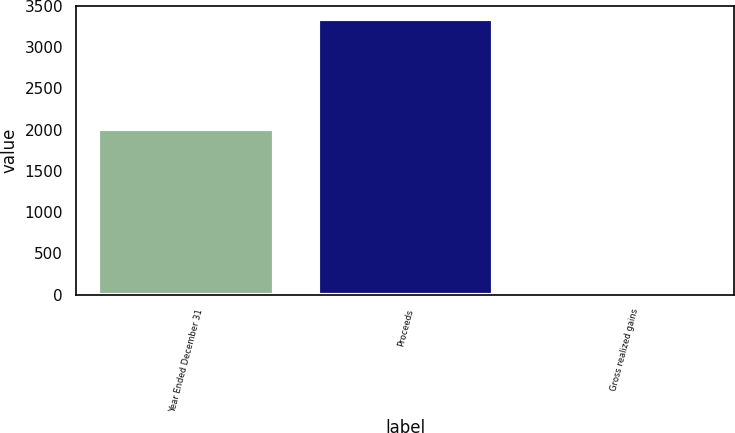Convert chart to OTSL. <chart><loc_0><loc_0><loc_500><loc_500><bar_chart><fcel>Year Ended December 31<fcel>Proceeds<fcel>Gross realized gains<nl><fcel>2012<fcel>3336<fcel>35<nl></chart> 